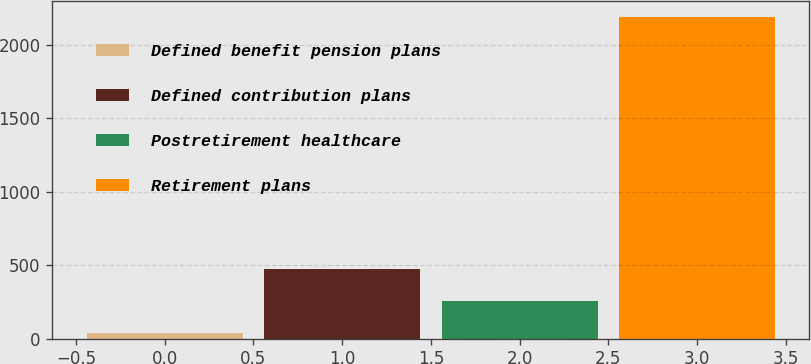Convert chart to OTSL. <chart><loc_0><loc_0><loc_500><loc_500><bar_chart><fcel>Defined benefit pension plans<fcel>Defined contribution plans<fcel>Postretirement healthcare<fcel>Retirement plans<nl><fcel>41<fcel>470.8<fcel>255.9<fcel>2190<nl></chart> 